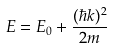<formula> <loc_0><loc_0><loc_500><loc_500>E = E _ { 0 } + \frac { ( \hbar { k } ) ^ { 2 } } { 2 m }</formula> 